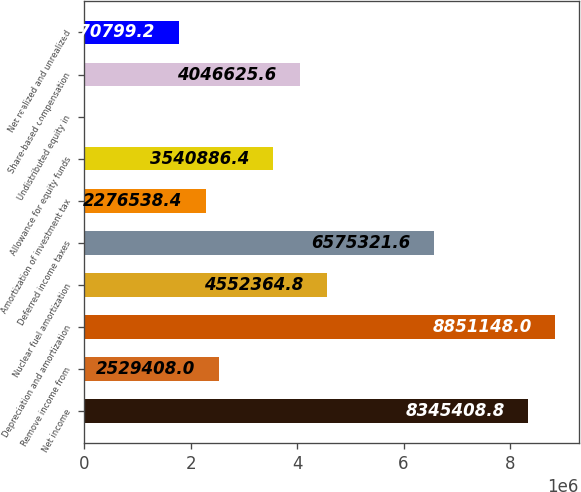Convert chart. <chart><loc_0><loc_0><loc_500><loc_500><bar_chart><fcel>Net income<fcel>Remove income from<fcel>Depreciation and amortization<fcel>Nuclear fuel amortization<fcel>Deferred income taxes<fcel>Amortization of investment tax<fcel>Allowance for equity funds<fcel>Undistributed equity in<fcel>Share-based compensation<fcel>Net realized and unrealized<nl><fcel>8.34541e+06<fcel>2.52941e+06<fcel>8.85115e+06<fcel>4.55236e+06<fcel>6.57532e+06<fcel>2.27654e+06<fcel>3.54089e+06<fcel>712<fcel>4.04663e+06<fcel>1.7708e+06<nl></chart> 